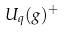Convert formula to latex. <formula><loc_0><loc_0><loc_500><loc_500>U _ { q } ( g ) ^ { + }</formula> 